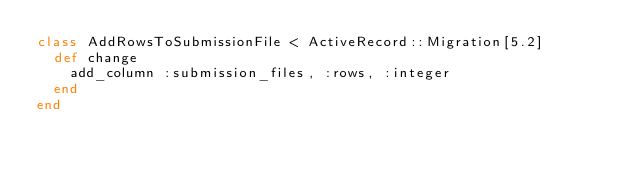<code> <loc_0><loc_0><loc_500><loc_500><_Ruby_>class AddRowsToSubmissionFile < ActiveRecord::Migration[5.2]
  def change
    add_column :submission_files, :rows, :integer
  end
end
</code> 